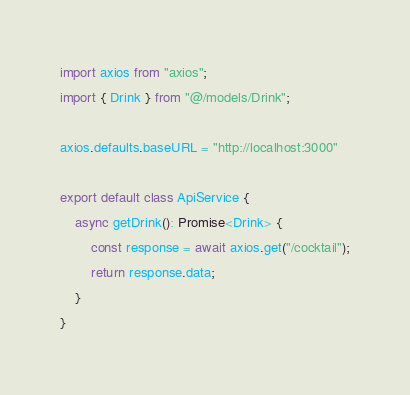Convert code to text. <code><loc_0><loc_0><loc_500><loc_500><_TypeScript_>import axios from "axios";
import { Drink } from "@/models/Drink";

axios.defaults.baseURL = "http://localhost:3000"

export default class ApiService {
    async getDrink(): Promise<Drink> {
        const response = await axios.get("/cocktail");
        return response.data;
    }
}
</code> 